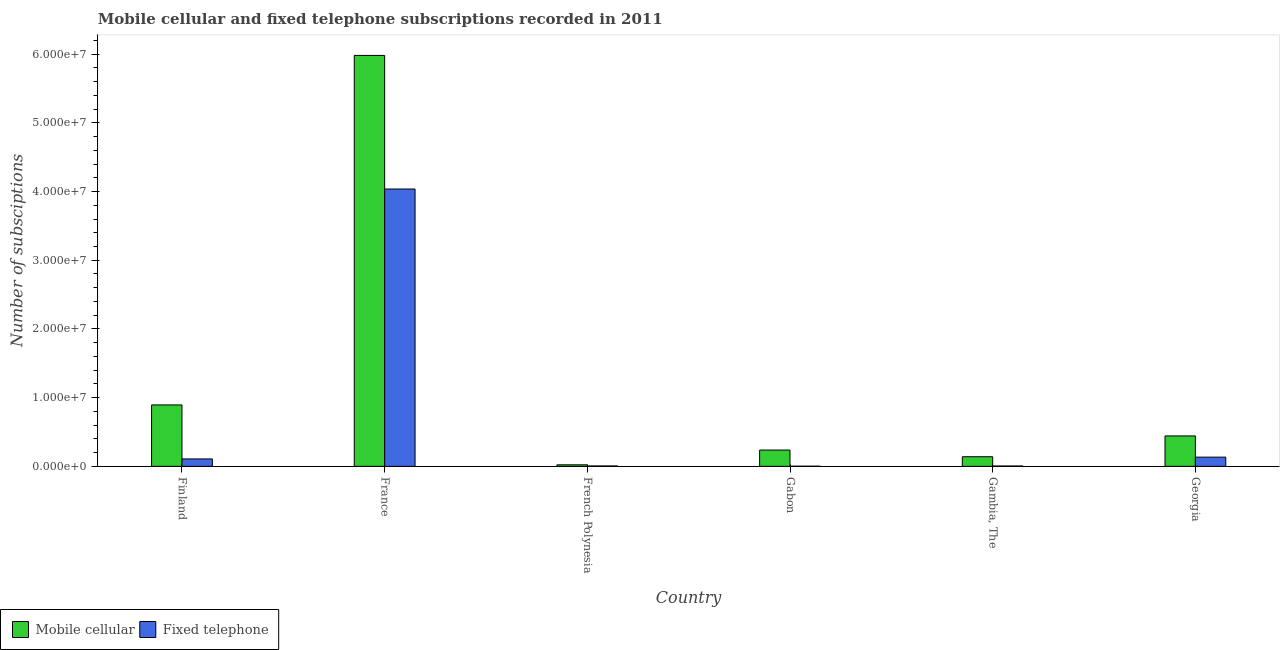How many different coloured bars are there?
Your response must be concise. 2. Are the number of bars per tick equal to the number of legend labels?
Offer a terse response. Yes. How many bars are there on the 4th tick from the left?
Offer a very short reply. 2. How many bars are there on the 1st tick from the right?
Offer a terse response. 2. What is the label of the 5th group of bars from the left?
Keep it short and to the point. Gambia, The. In how many cases, is the number of bars for a given country not equal to the number of legend labels?
Ensure brevity in your answer.  0. What is the number of mobile cellular subscriptions in Finland?
Give a very brief answer. 8.94e+06. Across all countries, what is the maximum number of fixed telephone subscriptions?
Offer a terse response. 4.04e+07. Across all countries, what is the minimum number of fixed telephone subscriptions?
Ensure brevity in your answer.  2.25e+04. In which country was the number of fixed telephone subscriptions minimum?
Provide a short and direct response. Gabon. What is the total number of mobile cellular subscriptions in the graph?
Your answer should be very brief. 7.72e+07. What is the difference between the number of fixed telephone subscriptions in Finland and that in French Polynesia?
Provide a succinct answer. 1.02e+06. What is the difference between the number of mobile cellular subscriptions in Gabon and the number of fixed telephone subscriptions in France?
Offer a terse response. -3.80e+07. What is the average number of mobile cellular subscriptions per country?
Give a very brief answer. 1.29e+07. What is the difference between the number of mobile cellular subscriptions and number of fixed telephone subscriptions in Gabon?
Your answer should be very brief. 2.35e+06. In how many countries, is the number of mobile cellular subscriptions greater than 34000000 ?
Keep it short and to the point. 1. What is the ratio of the number of mobile cellular subscriptions in French Polynesia to that in Gabon?
Offer a terse response. 0.09. Is the difference between the number of fixed telephone subscriptions in France and French Polynesia greater than the difference between the number of mobile cellular subscriptions in France and French Polynesia?
Give a very brief answer. No. What is the difference between the highest and the second highest number of mobile cellular subscriptions?
Keep it short and to the point. 5.09e+07. What is the difference between the highest and the lowest number of fixed telephone subscriptions?
Your answer should be compact. 4.03e+07. In how many countries, is the number of fixed telephone subscriptions greater than the average number of fixed telephone subscriptions taken over all countries?
Your answer should be very brief. 1. Is the sum of the number of mobile cellular subscriptions in Finland and Georgia greater than the maximum number of fixed telephone subscriptions across all countries?
Provide a short and direct response. No. What does the 2nd bar from the left in France represents?
Your response must be concise. Fixed telephone. What does the 1st bar from the right in Finland represents?
Your response must be concise. Fixed telephone. Are all the bars in the graph horizontal?
Ensure brevity in your answer.  No. How many countries are there in the graph?
Provide a succinct answer. 6. What is the difference between two consecutive major ticks on the Y-axis?
Keep it short and to the point. 1.00e+07. Are the values on the major ticks of Y-axis written in scientific E-notation?
Give a very brief answer. Yes. Where does the legend appear in the graph?
Offer a terse response. Bottom left. How many legend labels are there?
Keep it short and to the point. 2. What is the title of the graph?
Ensure brevity in your answer.  Mobile cellular and fixed telephone subscriptions recorded in 2011. What is the label or title of the X-axis?
Offer a terse response. Country. What is the label or title of the Y-axis?
Keep it short and to the point. Number of subsciptions. What is the Number of subsciptions of Mobile cellular in Finland?
Your answer should be very brief. 8.94e+06. What is the Number of subsciptions in Fixed telephone in Finland?
Provide a succinct answer. 1.08e+06. What is the Number of subsciptions in Mobile cellular in France?
Your answer should be compact. 5.98e+07. What is the Number of subsciptions of Fixed telephone in France?
Provide a short and direct response. 4.04e+07. What is the Number of subsciptions in Mobile cellular in French Polynesia?
Give a very brief answer. 2.23e+05. What is the Number of subsciptions in Fixed telephone in French Polynesia?
Ensure brevity in your answer.  5.50e+04. What is the Number of subsciptions in Mobile cellular in Gabon?
Keep it short and to the point. 2.37e+06. What is the Number of subsciptions of Fixed telephone in Gabon?
Offer a terse response. 2.25e+04. What is the Number of subsciptions in Mobile cellular in Gambia, The?
Make the answer very short. 1.40e+06. What is the Number of subsciptions in Fixed telephone in Gambia, The?
Offer a terse response. 5.04e+04. What is the Number of subsciptions in Mobile cellular in Georgia?
Provide a short and direct response. 4.43e+06. What is the Number of subsciptions of Fixed telephone in Georgia?
Ensure brevity in your answer.  1.34e+06. Across all countries, what is the maximum Number of subsciptions in Mobile cellular?
Give a very brief answer. 5.98e+07. Across all countries, what is the maximum Number of subsciptions of Fixed telephone?
Ensure brevity in your answer.  4.04e+07. Across all countries, what is the minimum Number of subsciptions in Mobile cellular?
Offer a very short reply. 2.23e+05. Across all countries, what is the minimum Number of subsciptions in Fixed telephone?
Give a very brief answer. 2.25e+04. What is the total Number of subsciptions in Mobile cellular in the graph?
Give a very brief answer. 7.72e+07. What is the total Number of subsciptions of Fixed telephone in the graph?
Provide a succinct answer. 4.29e+07. What is the difference between the Number of subsciptions in Mobile cellular in Finland and that in France?
Keep it short and to the point. -5.09e+07. What is the difference between the Number of subsciptions of Fixed telephone in Finland and that in France?
Offer a terse response. -3.93e+07. What is the difference between the Number of subsciptions of Mobile cellular in Finland and that in French Polynesia?
Provide a succinct answer. 8.72e+06. What is the difference between the Number of subsciptions of Fixed telephone in Finland and that in French Polynesia?
Make the answer very short. 1.02e+06. What is the difference between the Number of subsciptions in Mobile cellular in Finland and that in Gabon?
Your answer should be compact. 6.57e+06. What is the difference between the Number of subsciptions in Fixed telephone in Finland and that in Gabon?
Offer a terse response. 1.06e+06. What is the difference between the Number of subsciptions in Mobile cellular in Finland and that in Gambia, The?
Provide a succinct answer. 7.54e+06. What is the difference between the Number of subsciptions in Fixed telephone in Finland and that in Gambia, The?
Offer a terse response. 1.03e+06. What is the difference between the Number of subsciptions in Mobile cellular in Finland and that in Georgia?
Make the answer very short. 4.51e+06. What is the difference between the Number of subsciptions in Fixed telephone in Finland and that in Georgia?
Ensure brevity in your answer.  -2.60e+05. What is the difference between the Number of subsciptions of Mobile cellular in France and that in French Polynesia?
Your answer should be compact. 5.96e+07. What is the difference between the Number of subsciptions in Fixed telephone in France and that in French Polynesia?
Offer a terse response. 4.03e+07. What is the difference between the Number of subsciptions in Mobile cellular in France and that in Gabon?
Your answer should be very brief. 5.74e+07. What is the difference between the Number of subsciptions of Fixed telephone in France and that in Gabon?
Provide a succinct answer. 4.03e+07. What is the difference between the Number of subsciptions of Mobile cellular in France and that in Gambia, The?
Provide a short and direct response. 5.84e+07. What is the difference between the Number of subsciptions in Fixed telephone in France and that in Gambia, The?
Keep it short and to the point. 4.03e+07. What is the difference between the Number of subsciptions of Mobile cellular in France and that in Georgia?
Ensure brevity in your answer.  5.54e+07. What is the difference between the Number of subsciptions of Fixed telephone in France and that in Georgia?
Offer a very short reply. 3.90e+07. What is the difference between the Number of subsciptions in Mobile cellular in French Polynesia and that in Gabon?
Keep it short and to the point. -2.15e+06. What is the difference between the Number of subsciptions of Fixed telephone in French Polynesia and that in Gabon?
Make the answer very short. 3.25e+04. What is the difference between the Number of subsciptions of Mobile cellular in French Polynesia and that in Gambia, The?
Offer a very short reply. -1.18e+06. What is the difference between the Number of subsciptions in Fixed telephone in French Polynesia and that in Gambia, The?
Give a very brief answer. 4550. What is the difference between the Number of subsciptions of Mobile cellular in French Polynesia and that in Georgia?
Offer a very short reply. -4.21e+06. What is the difference between the Number of subsciptions in Fixed telephone in French Polynesia and that in Georgia?
Make the answer very short. -1.29e+06. What is the difference between the Number of subsciptions of Mobile cellular in Gabon and that in Gambia, The?
Your answer should be compact. 9.69e+05. What is the difference between the Number of subsciptions of Fixed telephone in Gabon and that in Gambia, The?
Keep it short and to the point. -2.80e+04. What is the difference between the Number of subsciptions of Mobile cellular in Gabon and that in Georgia?
Offer a terse response. -2.06e+06. What is the difference between the Number of subsciptions in Fixed telephone in Gabon and that in Georgia?
Provide a short and direct response. -1.32e+06. What is the difference between the Number of subsciptions of Mobile cellular in Gambia, The and that in Georgia?
Give a very brief answer. -3.03e+06. What is the difference between the Number of subsciptions of Fixed telephone in Gambia, The and that in Georgia?
Give a very brief answer. -1.29e+06. What is the difference between the Number of subsciptions in Mobile cellular in Finland and the Number of subsciptions in Fixed telephone in France?
Provide a succinct answer. -3.14e+07. What is the difference between the Number of subsciptions in Mobile cellular in Finland and the Number of subsciptions in Fixed telephone in French Polynesia?
Offer a terse response. 8.88e+06. What is the difference between the Number of subsciptions in Mobile cellular in Finland and the Number of subsciptions in Fixed telephone in Gabon?
Your response must be concise. 8.92e+06. What is the difference between the Number of subsciptions in Mobile cellular in Finland and the Number of subsciptions in Fixed telephone in Gambia, The?
Your response must be concise. 8.89e+06. What is the difference between the Number of subsciptions in Mobile cellular in Finland and the Number of subsciptions in Fixed telephone in Georgia?
Your response must be concise. 7.60e+06. What is the difference between the Number of subsciptions in Mobile cellular in France and the Number of subsciptions in Fixed telephone in French Polynesia?
Give a very brief answer. 5.98e+07. What is the difference between the Number of subsciptions of Mobile cellular in France and the Number of subsciptions of Fixed telephone in Gabon?
Offer a very short reply. 5.98e+07. What is the difference between the Number of subsciptions in Mobile cellular in France and the Number of subsciptions in Fixed telephone in Gambia, The?
Provide a short and direct response. 5.98e+07. What is the difference between the Number of subsciptions of Mobile cellular in France and the Number of subsciptions of Fixed telephone in Georgia?
Provide a succinct answer. 5.85e+07. What is the difference between the Number of subsciptions in Mobile cellular in French Polynesia and the Number of subsciptions in Fixed telephone in Gabon?
Your response must be concise. 2.00e+05. What is the difference between the Number of subsciptions in Mobile cellular in French Polynesia and the Number of subsciptions in Fixed telephone in Gambia, The?
Provide a succinct answer. 1.72e+05. What is the difference between the Number of subsciptions of Mobile cellular in French Polynesia and the Number of subsciptions of Fixed telephone in Georgia?
Your response must be concise. -1.12e+06. What is the difference between the Number of subsciptions of Mobile cellular in Gabon and the Number of subsciptions of Fixed telephone in Gambia, The?
Make the answer very short. 2.32e+06. What is the difference between the Number of subsciptions of Mobile cellular in Gabon and the Number of subsciptions of Fixed telephone in Georgia?
Your answer should be compact. 1.03e+06. What is the difference between the Number of subsciptions of Mobile cellular in Gambia, The and the Number of subsciptions of Fixed telephone in Georgia?
Keep it short and to the point. 6.07e+04. What is the average Number of subsciptions in Mobile cellular per country?
Your response must be concise. 1.29e+07. What is the average Number of subsciptions of Fixed telephone per country?
Provide a succinct answer. 7.15e+06. What is the difference between the Number of subsciptions in Mobile cellular and Number of subsciptions in Fixed telephone in Finland?
Offer a very short reply. 7.86e+06. What is the difference between the Number of subsciptions of Mobile cellular and Number of subsciptions of Fixed telephone in France?
Your answer should be very brief. 1.94e+07. What is the difference between the Number of subsciptions in Mobile cellular and Number of subsciptions in Fixed telephone in French Polynesia?
Offer a very short reply. 1.68e+05. What is the difference between the Number of subsciptions in Mobile cellular and Number of subsciptions in Fixed telephone in Gabon?
Your answer should be very brief. 2.35e+06. What is the difference between the Number of subsciptions of Mobile cellular and Number of subsciptions of Fixed telephone in Gambia, The?
Your answer should be very brief. 1.35e+06. What is the difference between the Number of subsciptions of Mobile cellular and Number of subsciptions of Fixed telephone in Georgia?
Give a very brief answer. 3.09e+06. What is the ratio of the Number of subsciptions of Mobile cellular in Finland to that in France?
Ensure brevity in your answer.  0.15. What is the ratio of the Number of subsciptions in Fixed telephone in Finland to that in France?
Keep it short and to the point. 0.03. What is the ratio of the Number of subsciptions of Mobile cellular in Finland to that in French Polynesia?
Offer a very short reply. 40.12. What is the ratio of the Number of subsciptions of Fixed telephone in Finland to that in French Polynesia?
Offer a very short reply. 19.64. What is the ratio of the Number of subsciptions of Mobile cellular in Finland to that in Gabon?
Ensure brevity in your answer.  3.77. What is the ratio of the Number of subsciptions in Fixed telephone in Finland to that in Gabon?
Your answer should be very brief. 48. What is the ratio of the Number of subsciptions of Mobile cellular in Finland to that in Gambia, The?
Make the answer very short. 6.38. What is the ratio of the Number of subsciptions in Fixed telephone in Finland to that in Gambia, The?
Your answer should be very brief. 21.41. What is the ratio of the Number of subsciptions in Mobile cellular in Finland to that in Georgia?
Keep it short and to the point. 2.02. What is the ratio of the Number of subsciptions of Fixed telephone in Finland to that in Georgia?
Your answer should be compact. 0.81. What is the ratio of the Number of subsciptions in Mobile cellular in France to that in French Polynesia?
Ensure brevity in your answer.  268.44. What is the ratio of the Number of subsciptions of Fixed telephone in France to that in French Polynesia?
Give a very brief answer. 734. What is the ratio of the Number of subsciptions in Mobile cellular in France to that in Gabon?
Provide a succinct answer. 25.24. What is the ratio of the Number of subsciptions in Fixed telephone in France to that in Gabon?
Provide a succinct answer. 1794.3. What is the ratio of the Number of subsciptions of Mobile cellular in France to that in Gambia, The?
Your answer should be very brief. 42.69. What is the ratio of the Number of subsciptions in Fixed telephone in France to that in Gambia, The?
Ensure brevity in your answer.  800.2. What is the ratio of the Number of subsciptions in Mobile cellular in France to that in Georgia?
Keep it short and to the point. 13.5. What is the ratio of the Number of subsciptions in Fixed telephone in France to that in Georgia?
Make the answer very short. 30.12. What is the ratio of the Number of subsciptions of Mobile cellular in French Polynesia to that in Gabon?
Your response must be concise. 0.09. What is the ratio of the Number of subsciptions in Fixed telephone in French Polynesia to that in Gabon?
Your answer should be very brief. 2.44. What is the ratio of the Number of subsciptions in Mobile cellular in French Polynesia to that in Gambia, The?
Provide a short and direct response. 0.16. What is the ratio of the Number of subsciptions of Fixed telephone in French Polynesia to that in Gambia, The?
Your answer should be compact. 1.09. What is the ratio of the Number of subsciptions in Mobile cellular in French Polynesia to that in Georgia?
Keep it short and to the point. 0.05. What is the ratio of the Number of subsciptions of Fixed telephone in French Polynesia to that in Georgia?
Provide a succinct answer. 0.04. What is the ratio of the Number of subsciptions in Mobile cellular in Gabon to that in Gambia, The?
Make the answer very short. 1.69. What is the ratio of the Number of subsciptions in Fixed telephone in Gabon to that in Gambia, The?
Offer a very short reply. 0.45. What is the ratio of the Number of subsciptions of Mobile cellular in Gabon to that in Georgia?
Ensure brevity in your answer.  0.54. What is the ratio of the Number of subsciptions of Fixed telephone in Gabon to that in Georgia?
Provide a succinct answer. 0.02. What is the ratio of the Number of subsciptions in Mobile cellular in Gambia, The to that in Georgia?
Keep it short and to the point. 0.32. What is the ratio of the Number of subsciptions of Fixed telephone in Gambia, The to that in Georgia?
Provide a short and direct response. 0.04. What is the difference between the highest and the second highest Number of subsciptions in Mobile cellular?
Your answer should be compact. 5.09e+07. What is the difference between the highest and the second highest Number of subsciptions of Fixed telephone?
Provide a succinct answer. 3.90e+07. What is the difference between the highest and the lowest Number of subsciptions of Mobile cellular?
Your answer should be very brief. 5.96e+07. What is the difference between the highest and the lowest Number of subsciptions of Fixed telephone?
Offer a terse response. 4.03e+07. 